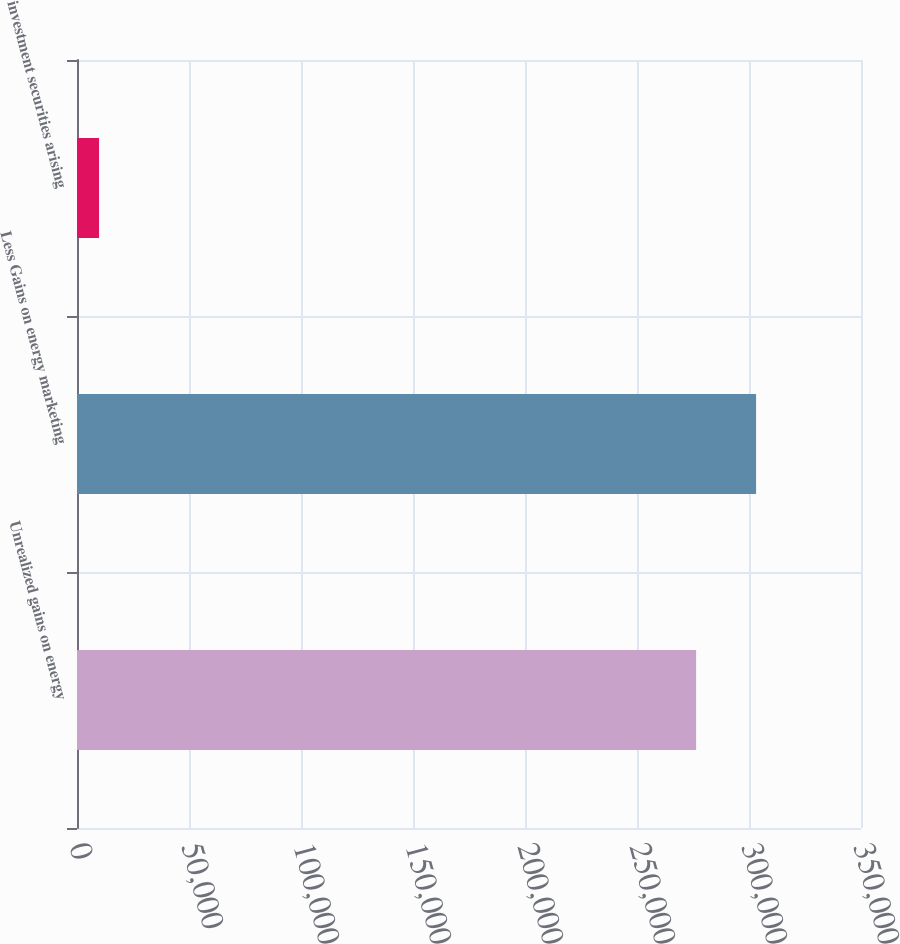Convert chart to OTSL. <chart><loc_0><loc_0><loc_500><loc_500><bar_chart><fcel>Unrealized gains on energy<fcel>Less Gains on energy marketing<fcel>investment securities arising<nl><fcel>276400<fcel>303158<fcel>9837<nl></chart> 